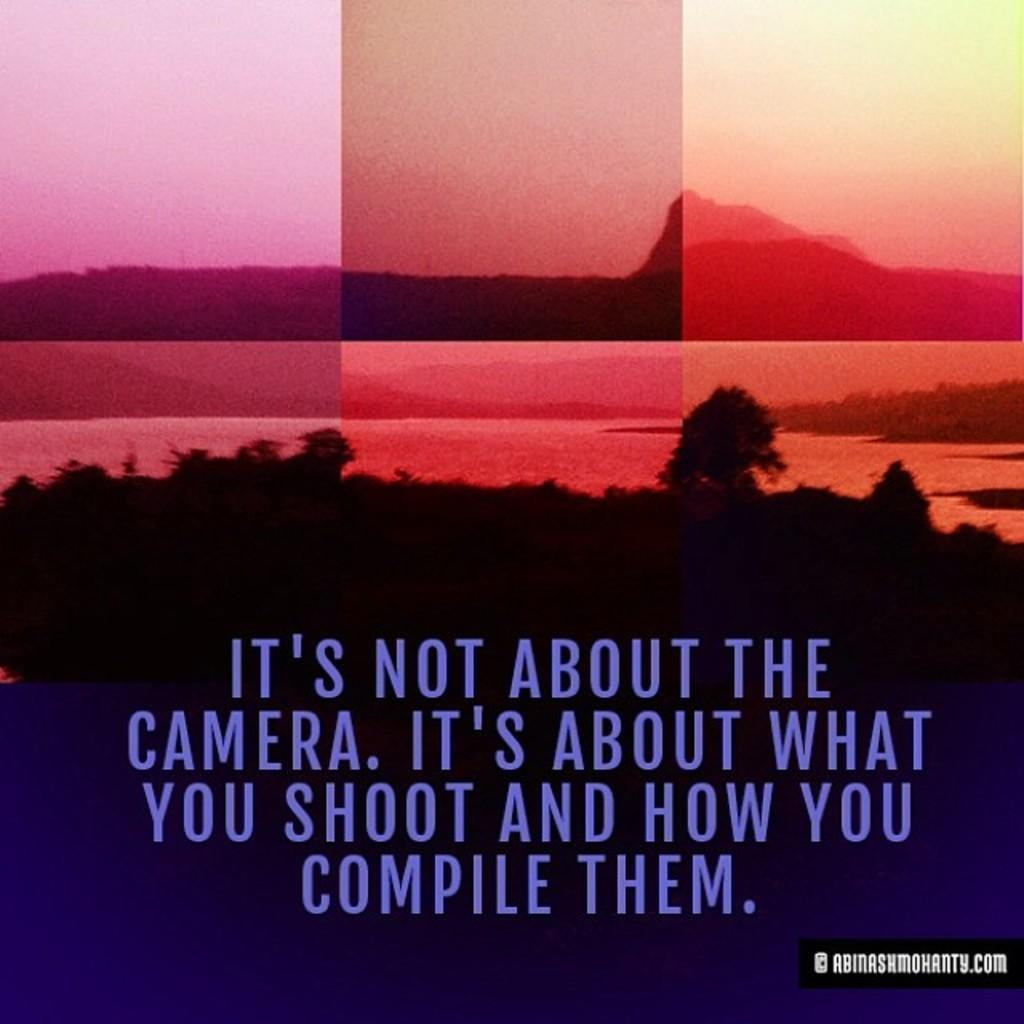<image>
Write a terse but informative summary of the picture. An ad that says, "It's not about the camera" with an image of a landscape. 